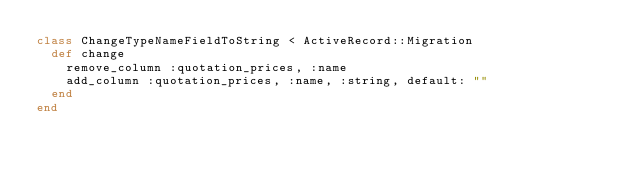<code> <loc_0><loc_0><loc_500><loc_500><_Ruby_>class ChangeTypeNameFieldToString < ActiveRecord::Migration
  def change
    remove_column :quotation_prices, :name
    add_column :quotation_prices, :name, :string, default: ""
  end
end
</code> 